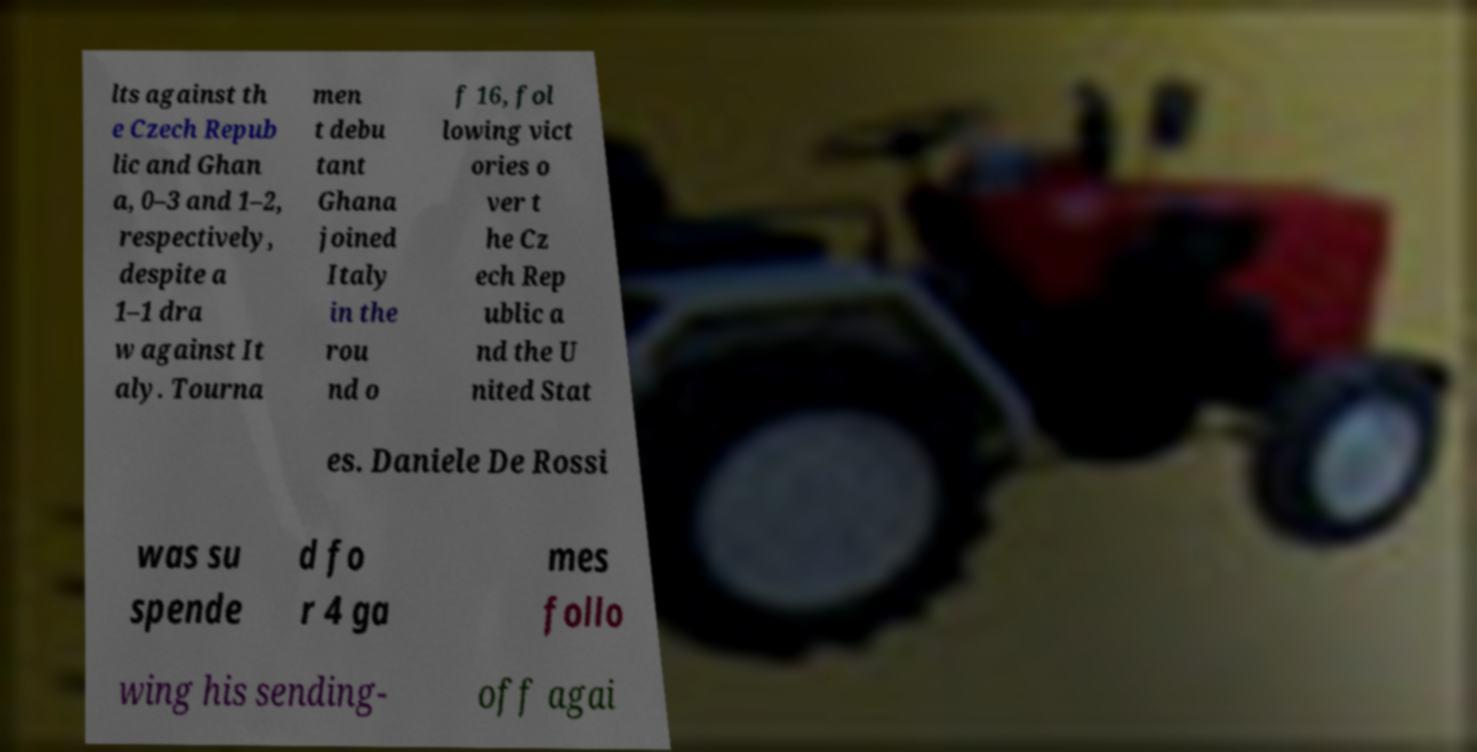Please read and relay the text visible in this image. What does it say? lts against th e Czech Repub lic and Ghan a, 0–3 and 1–2, respectively, despite a 1–1 dra w against It aly. Tourna men t debu tant Ghana joined Italy in the rou nd o f 16, fol lowing vict ories o ver t he Cz ech Rep ublic a nd the U nited Stat es. Daniele De Rossi was su spende d fo r 4 ga mes follo wing his sending- off agai 